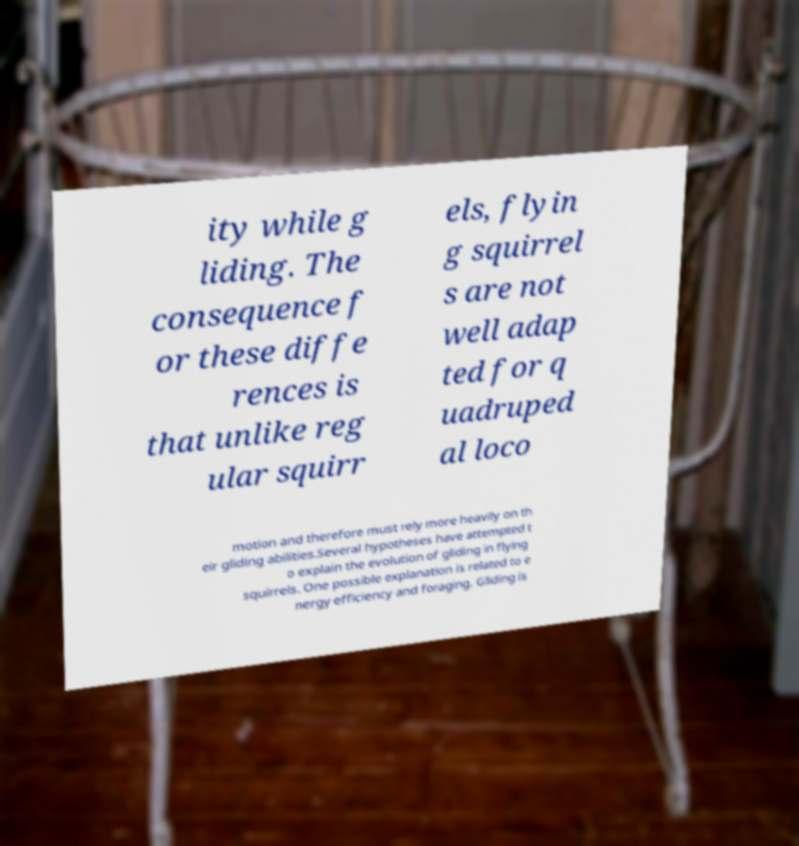Can you accurately transcribe the text from the provided image for me? ity while g liding. The consequence f or these diffe rences is that unlike reg ular squirr els, flyin g squirrel s are not well adap ted for q uadruped al loco motion and therefore must rely more heavily on th eir gliding abilities.Several hypotheses have attempted t o explain the evolution of gliding in flying squirrels. One possible explanation is related to e nergy efficiency and foraging. Gliding is 